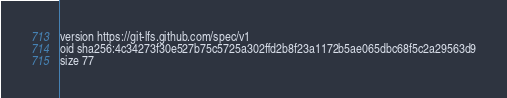Convert code to text. <code><loc_0><loc_0><loc_500><loc_500><_YAML_>version https://git-lfs.github.com/spec/v1
oid sha256:4c34273f30e527b75c5725a302ffd2b8f23a1172b5ae065dbc68f5c2a29563d9
size 77
</code> 